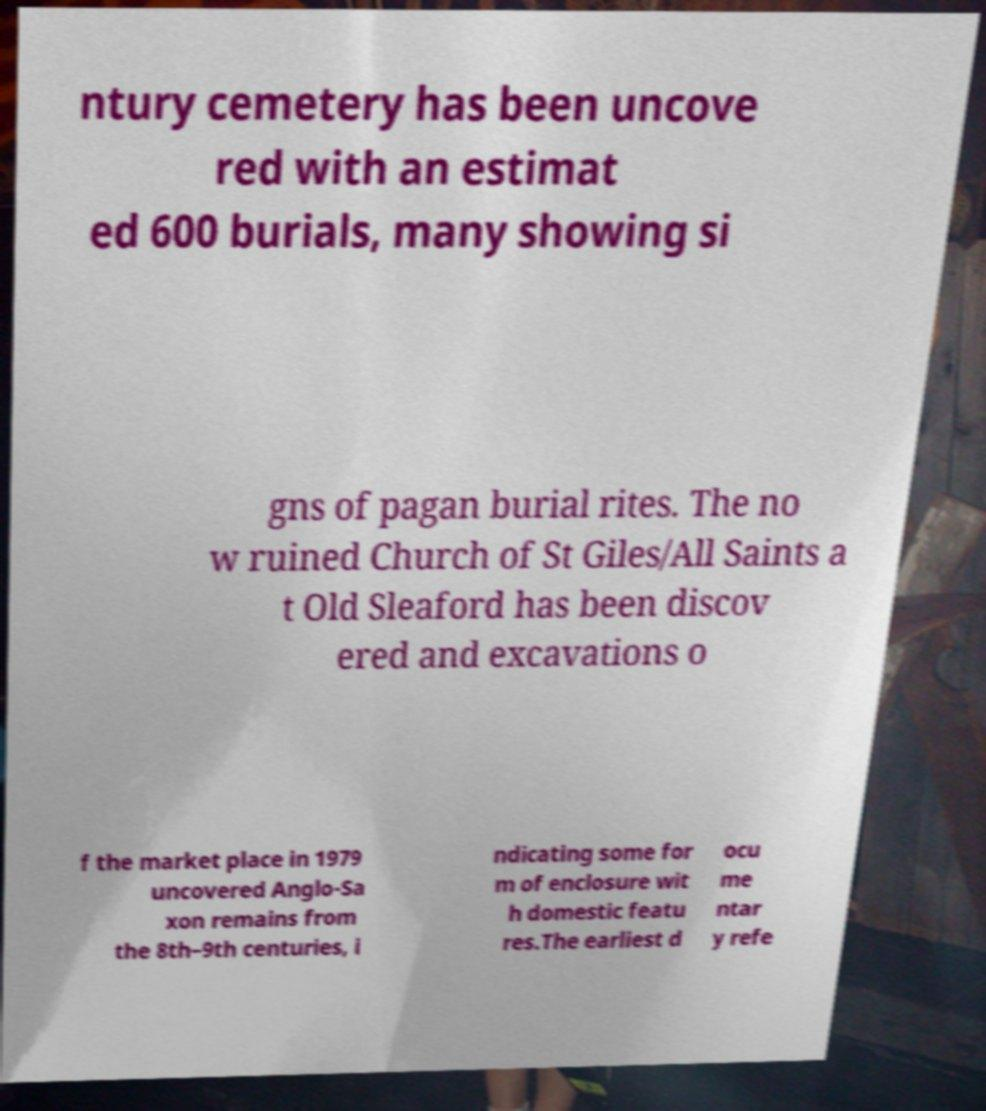Could you extract and type out the text from this image? ntury cemetery has been uncove red with an estimat ed 600 burials, many showing si gns of pagan burial rites. The no w ruined Church of St Giles/All Saints a t Old Sleaford has been discov ered and excavations o f the market place in 1979 uncovered Anglo-Sa xon remains from the 8th–9th centuries, i ndicating some for m of enclosure wit h domestic featu res.The earliest d ocu me ntar y refe 